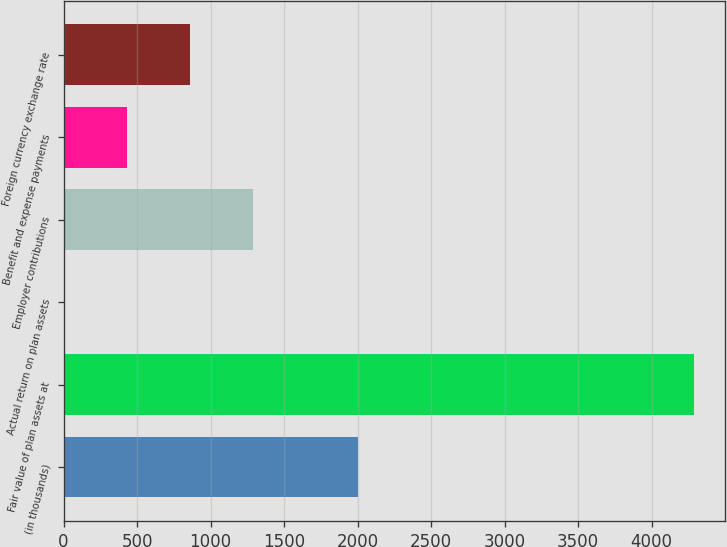<chart> <loc_0><loc_0><loc_500><loc_500><bar_chart><fcel>(in thousands)<fcel>Fair value of plan assets at<fcel>Actual return on plan assets<fcel>Employer contributions<fcel>Benefit and expense payments<fcel>Foreign currency exchange rate<nl><fcel>2005<fcel>4285<fcel>1<fcel>1286.2<fcel>429.4<fcel>857.8<nl></chart> 